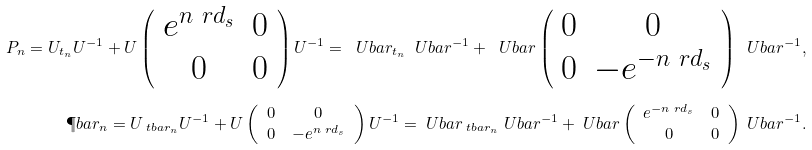Convert formula to latex. <formula><loc_0><loc_0><loc_500><loc_500>P _ { n } = U _ { t _ { n } } U ^ { - 1 } + U \left ( \begin{array} { c c } e ^ { n \ r d _ { s } } & 0 \\ 0 & 0 \end{array} \right ) U ^ { - 1 } = \ U b a r _ { t _ { n } } \ U b a r ^ { - 1 } + \ U b a r \left ( \begin{array} { c c } 0 & 0 \\ 0 & - e ^ { - n \ r d _ { s } } \end{array} \right ) \ U b a r ^ { - 1 } , \\ \P b a r _ { n } = U _ { \ t b a r _ { n } } U ^ { - 1 } + U \left ( \begin{array} { c c } 0 & 0 \\ 0 & - e ^ { n \ r d _ { s } } \end{array} \right ) U ^ { - 1 } = \ U b a r _ { \ t b a r _ { n } } \ U b a r ^ { - 1 } + \ U b a r \left ( \begin{array} { c c } e ^ { - n \ r d _ { s } } & 0 \\ 0 & 0 \end{array} \right ) \ U b a r ^ { - 1 } .</formula> 